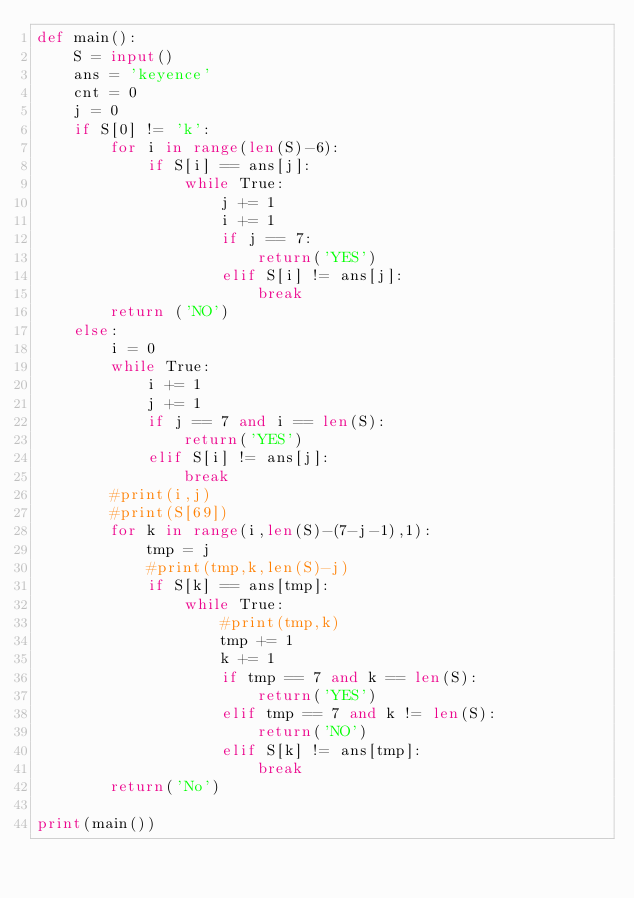<code> <loc_0><loc_0><loc_500><loc_500><_Python_>def main():
    S = input()
    ans = 'keyence'
    cnt = 0
    j = 0
    if S[0] != 'k':
        for i in range(len(S)-6):
            if S[i] == ans[j]:
                while True:
                    j += 1
                    i += 1
                    if j == 7:
                        return('YES')
                    elif S[i] != ans[j]:
                        break
        return ('NO')
    else:
        i = 0
        while True:
            i += 1
            j += 1
            if j == 7 and i == len(S):
                return('YES')
            elif S[i] != ans[j]:
                break
        #print(i,j)
        #print(S[69])
        for k in range(i,len(S)-(7-j-1),1):
            tmp = j
            #print(tmp,k,len(S)-j)
            if S[k] == ans[tmp]:
                while True:
                    #print(tmp,k)
                    tmp += 1
                    k += 1
                    if tmp == 7 and k == len(S):
                        return('YES')
                    elif tmp == 7 and k != len(S):
                        return('NO')
                    elif S[k] != ans[tmp]:
                        break
        return('No')

print(main())
</code> 